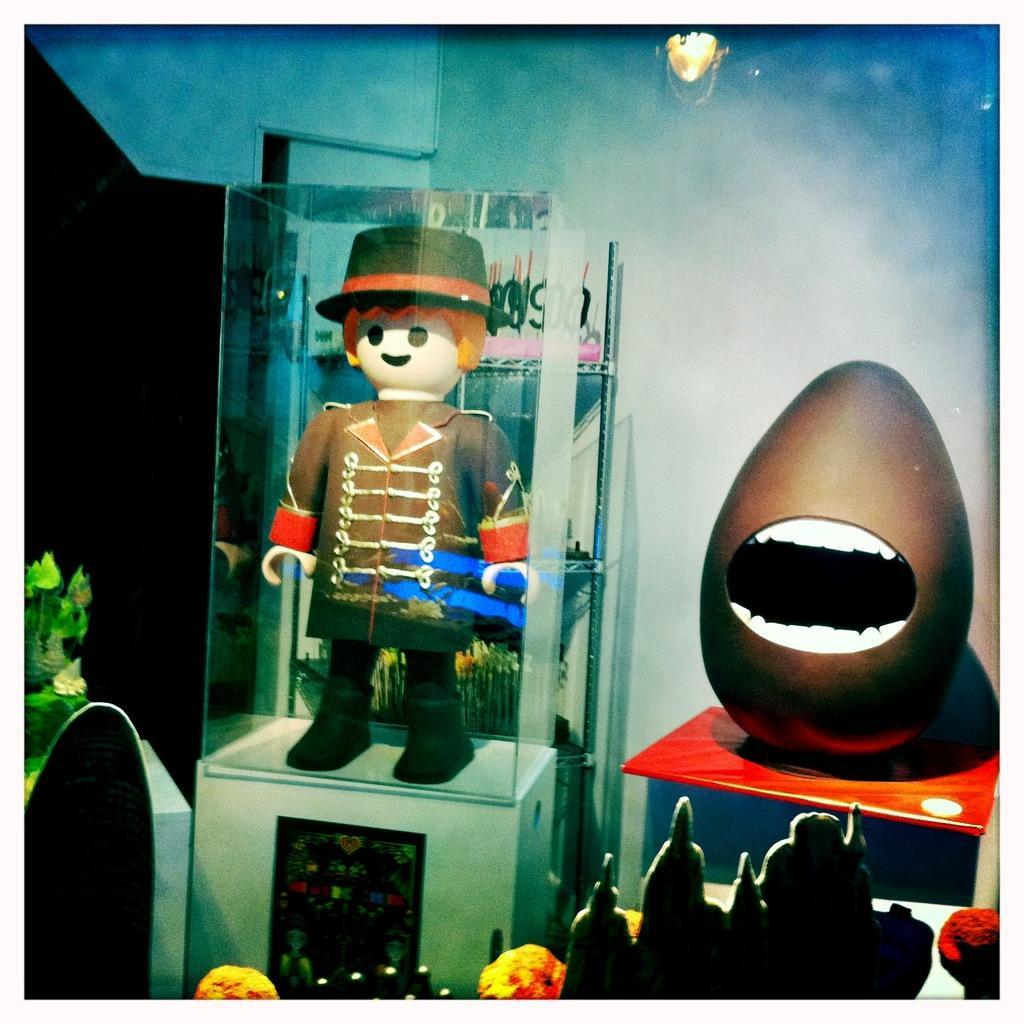Please provide a concise description of this image. In this image we can see the depiction of a man in the display. We can also see the toys and also some objects. Image also consists of the lights and also the wall. 